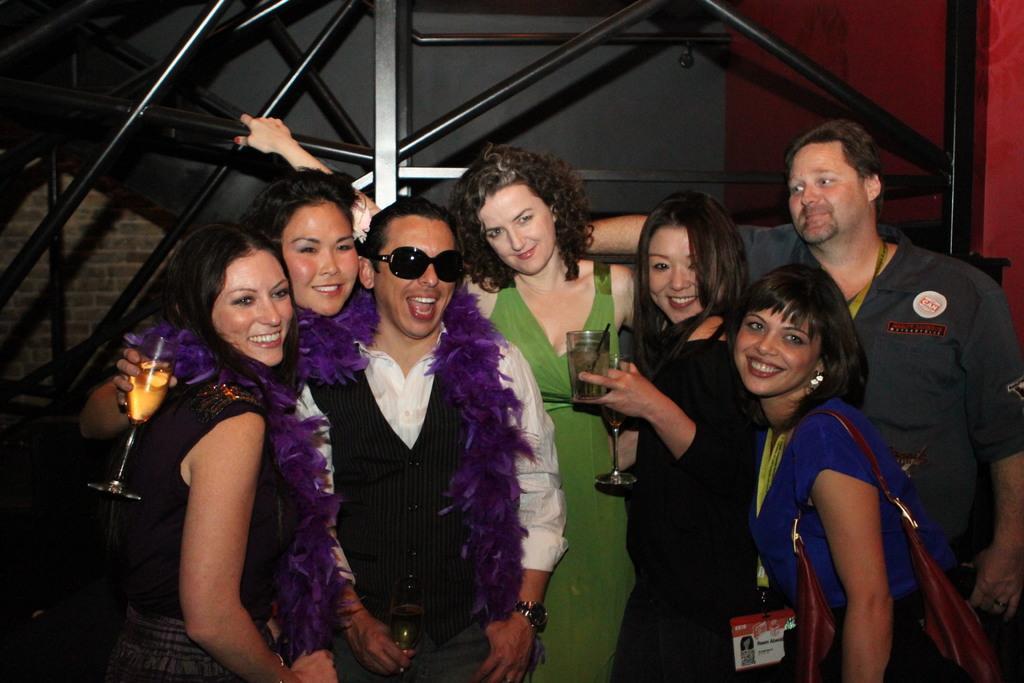Could you give a brief overview of what you see in this image? In this image we can see people, rods and wall. Among them two people are holding bottles and one woman wore handbag. 